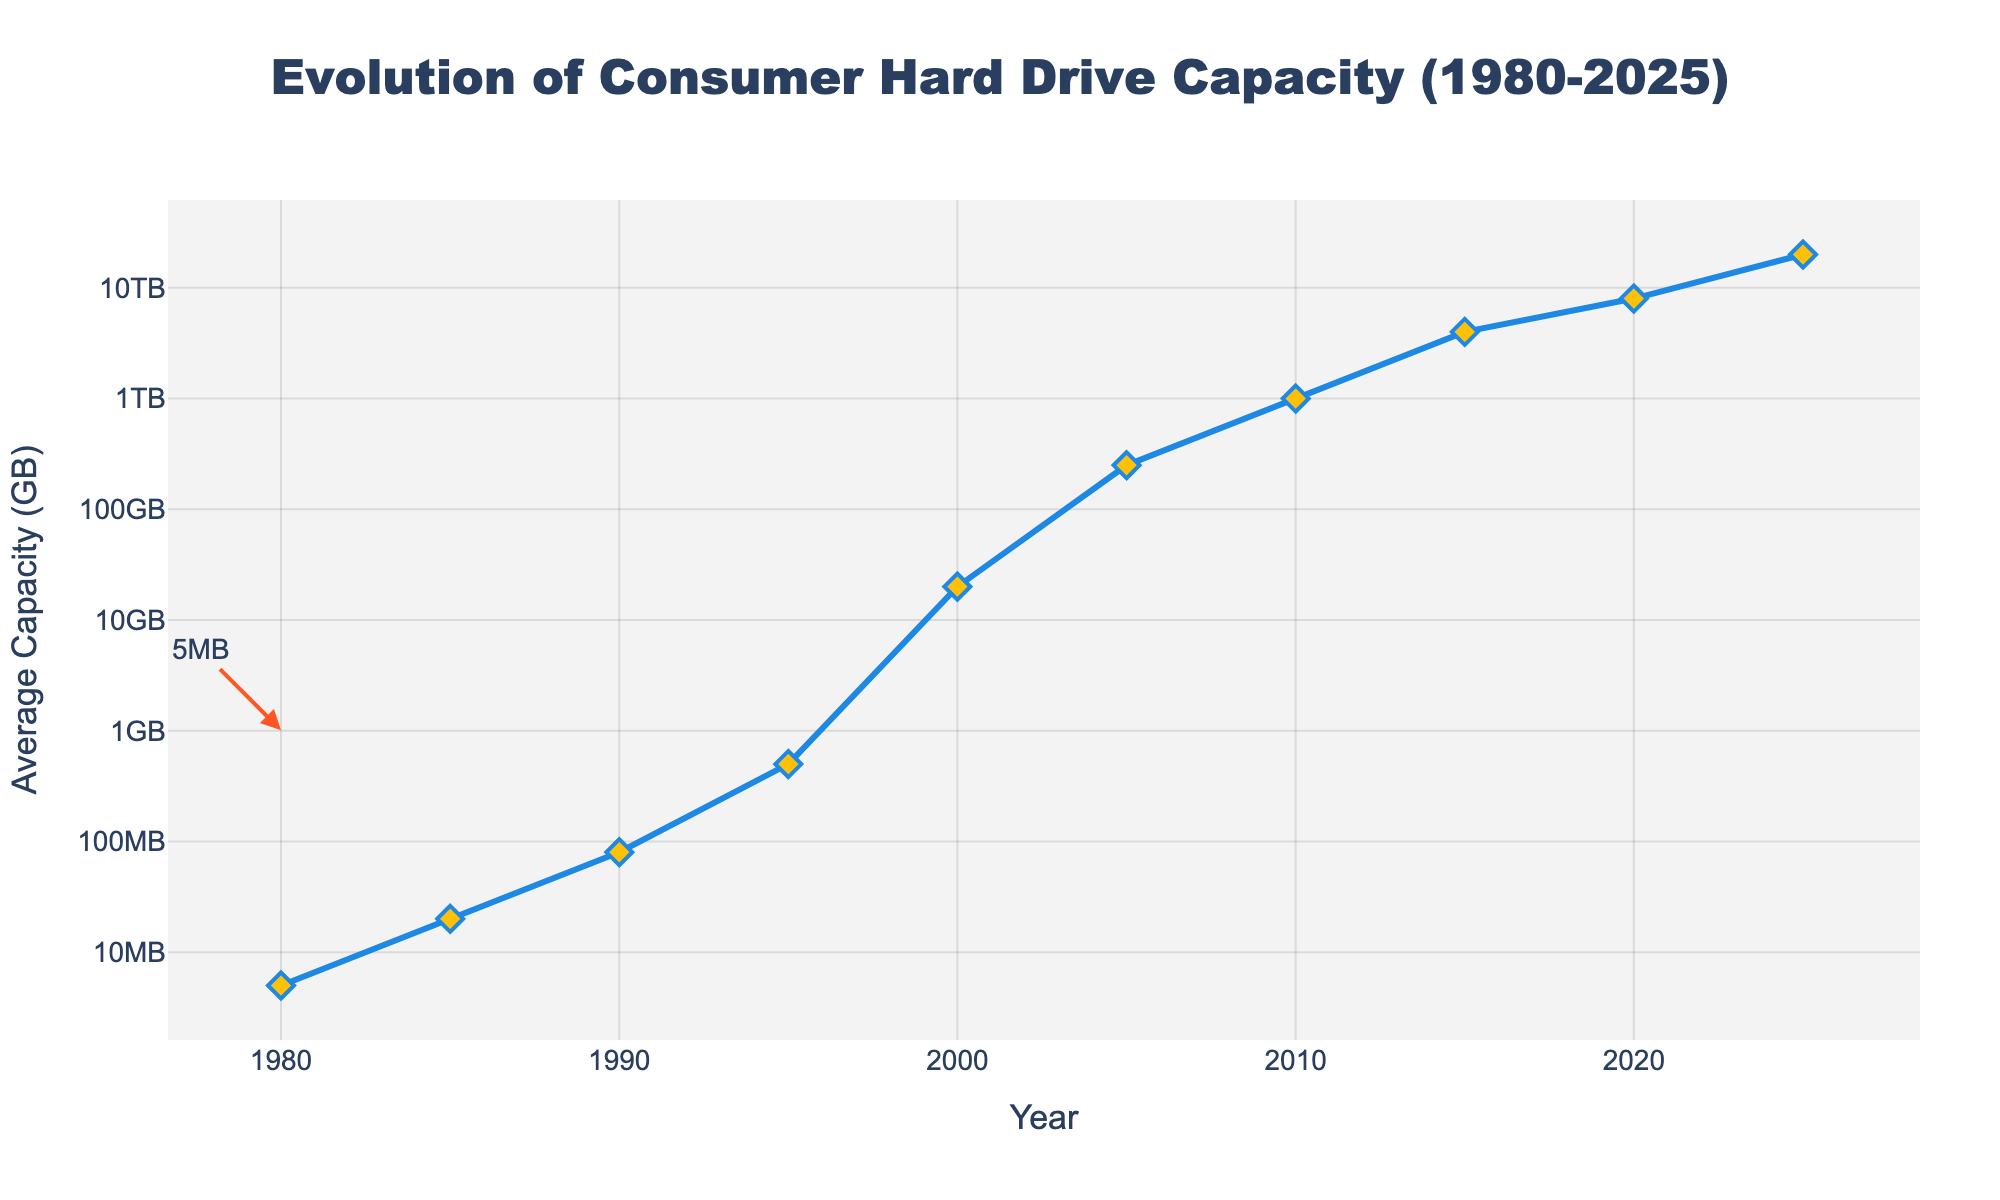What's the average capacity in 2000? Locate the year 2000 on the x-axis and the corresponding data point on the line. The figure shows the average capacity as 20GB.
Answer: 20GB How much did the average capacity increase from 1980 to 2000? Find the average capacities for 1980 and 2000, which are 0.005GB and 20GB. Subtract the 1980 value from the 2000 value: 20GB - 0.005GB.
Answer: 19.995GB Which year experienced the highest average hard drive capacity? Look at the endpoint on the right side of the x-axis representing 2025 with the highest average capacity recorded on the y-axis.
Answer: 2025 What is the approximate average capacity in 2020? Find the year 2020 on the x-axis and check the y-axis value the data point aligns with. The figure shows 8000GB.
Answer: 8000GB By how much did the average capacity increase between 2015 and 2025? Compare the values for 2015 and 2025. The capacities are 4000GB and 20000GB respectively. Subtract the 2015 value from the 2025 value: 20000GB - 4000GB.
Answer: 16000GB How does the average capacity in 1985 compare to that in 1990? Look for the values in both years. In 1985, it's 0.02GB, and in 1990, it's 0.08GB. Notice that 1990 is higher than 1985.
Answer: 1990 is higher What's the ratio of the average capacity in 2005 to that in 1995? Find the capacity values for 2005 and 1995, which are 250GB and 0.5GB. Divide the 2005 value by the 1995 value: 250GB / 0.5GB.
Answer: 500 Which decade saw the most significant increase in average capacity? Observe the graph and compare the slopes of the line in each decade. The steepest slope appears between 2000 (20GB) and 2010 (1000GB).
Answer: 2000 to 2010 By what factor did the average capacity increase from 1995 to 2020? Identify the capacities for 1995 and 2020, which are 0.5GB and 8000GB. Divide the 2020 value by the 1995 value: 8000GB / 0.5GB.
Answer: 16000 What color represents the data points on the line? Visually inspect the markers on the line, which are diamond-shaped and colored in yellow.
Answer: Yellow 